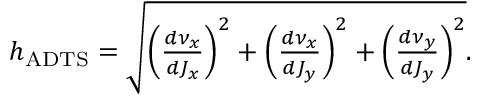<formula> <loc_0><loc_0><loc_500><loc_500>\begin{array} { r } { h _ { A D T S } = \sqrt { \left ( \frac { d \nu _ { x } } { d J _ { x } } \right ) ^ { 2 } + \left ( \frac { d \nu _ { x } } { d J _ { y } } \right ) ^ { 2 } + \left ( \frac { d \nu _ { y } } { d J _ { y } } \right ) ^ { 2 } } . } \end{array}</formula> 